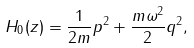<formula> <loc_0><loc_0><loc_500><loc_500>H _ { 0 } ( z ) = \frac { 1 } { 2 m } p ^ { 2 } + \frac { m \omega ^ { 2 } } { 2 } q ^ { 2 } ,</formula> 